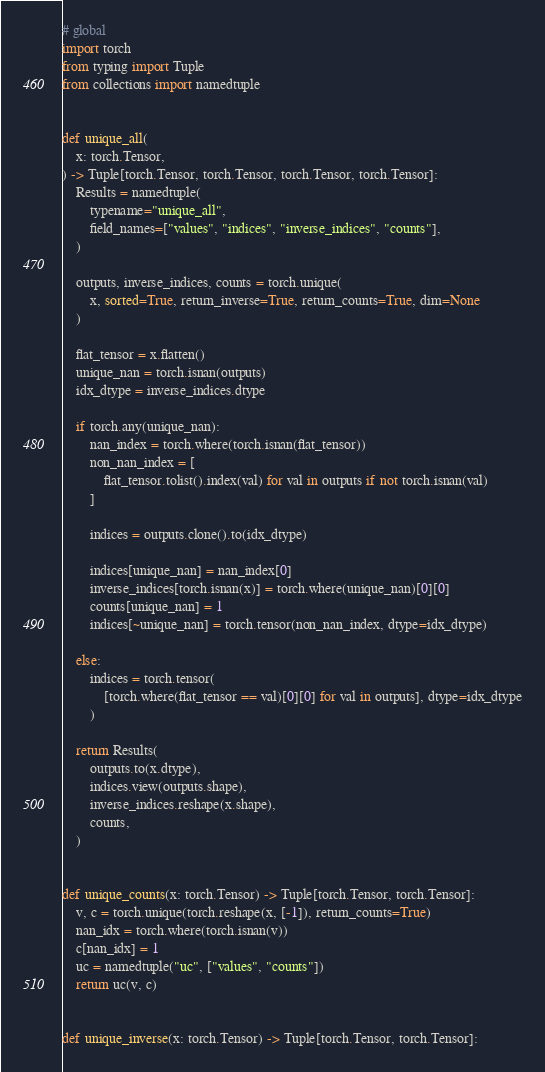<code> <loc_0><loc_0><loc_500><loc_500><_Python_># global
import torch
from typing import Tuple
from collections import namedtuple


def unique_all(
    x: torch.Tensor,
) -> Tuple[torch.Tensor, torch.Tensor, torch.Tensor, torch.Tensor]:
    Results = namedtuple(
        typename="unique_all",
        field_names=["values", "indices", "inverse_indices", "counts"],
    )

    outputs, inverse_indices, counts = torch.unique(
        x, sorted=True, return_inverse=True, return_counts=True, dim=None
    )

    flat_tensor = x.flatten()
    unique_nan = torch.isnan(outputs)
    idx_dtype = inverse_indices.dtype

    if torch.any(unique_nan):
        nan_index = torch.where(torch.isnan(flat_tensor))
        non_nan_index = [
            flat_tensor.tolist().index(val) for val in outputs if not torch.isnan(val)
        ]

        indices = outputs.clone().to(idx_dtype)

        indices[unique_nan] = nan_index[0]
        inverse_indices[torch.isnan(x)] = torch.where(unique_nan)[0][0]
        counts[unique_nan] = 1
        indices[~unique_nan] = torch.tensor(non_nan_index, dtype=idx_dtype)

    else:
        indices = torch.tensor(
            [torch.where(flat_tensor == val)[0][0] for val in outputs], dtype=idx_dtype
        )

    return Results(
        outputs.to(x.dtype),
        indices.view(outputs.shape),
        inverse_indices.reshape(x.shape),
        counts,
    )


def unique_counts(x: torch.Tensor) -> Tuple[torch.Tensor, torch.Tensor]:
    v, c = torch.unique(torch.reshape(x, [-1]), return_counts=True)
    nan_idx = torch.where(torch.isnan(v))
    c[nan_idx] = 1
    uc = namedtuple("uc", ["values", "counts"])
    return uc(v, c)


def unique_inverse(x: torch.Tensor) -> Tuple[torch.Tensor, torch.Tensor]:</code> 